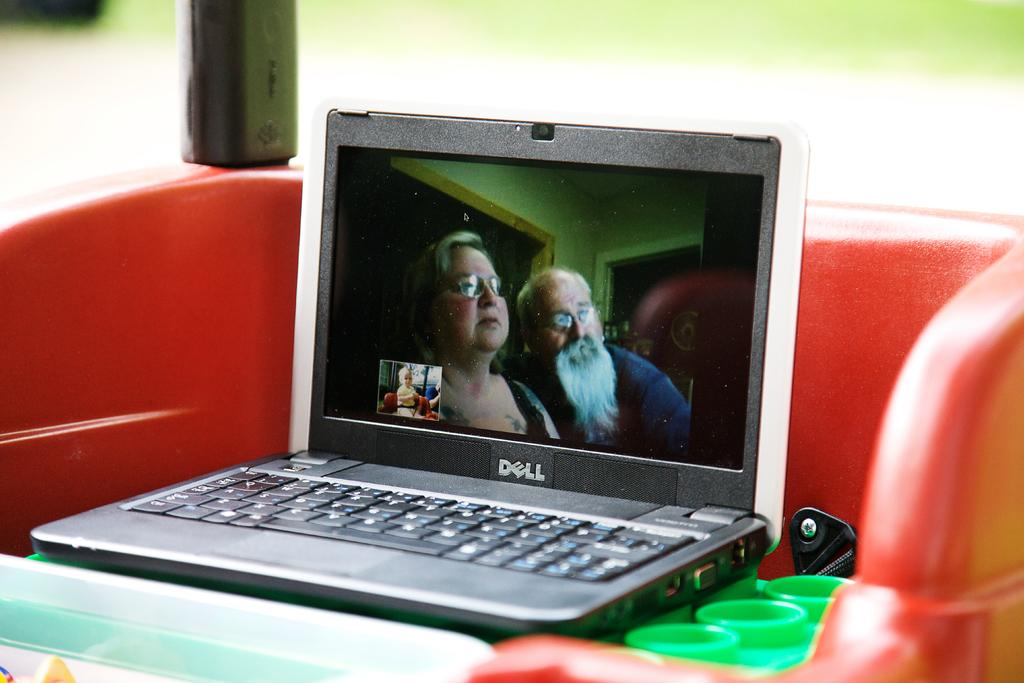Provide a one-sentence caption for the provided image. A movie is being played on a Dell laptop. 